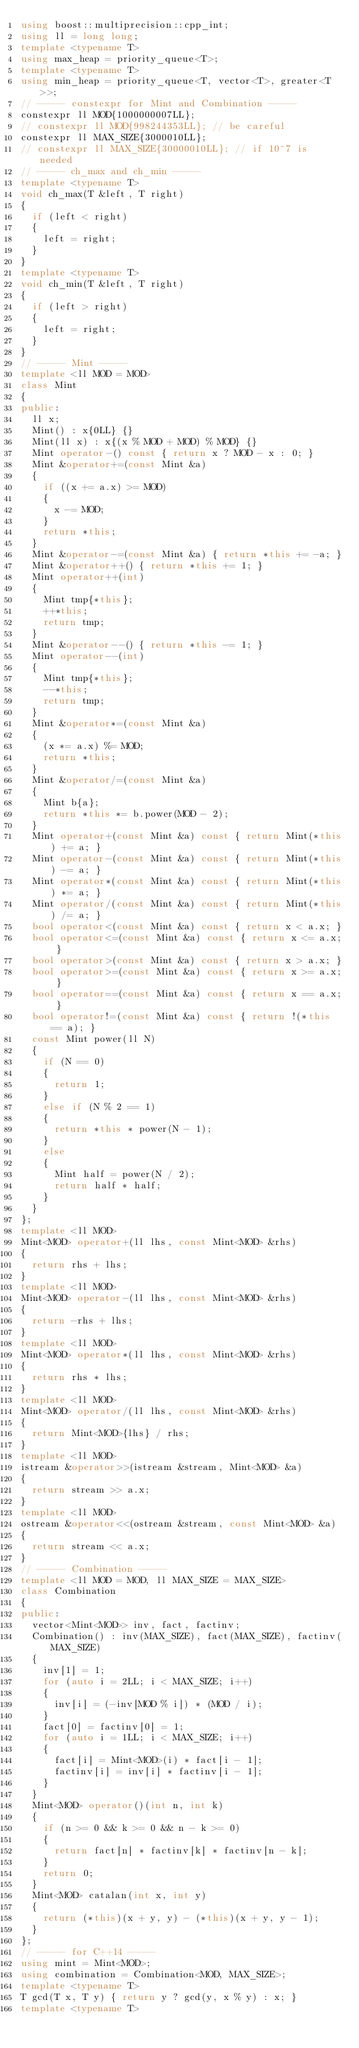<code> <loc_0><loc_0><loc_500><loc_500><_C++_>using boost::multiprecision::cpp_int;
using ll = long long;
template <typename T>
using max_heap = priority_queue<T>;
template <typename T>
using min_heap = priority_queue<T, vector<T>, greater<T>>;
// ----- constexpr for Mint and Combination -----
constexpr ll MOD{1000000007LL};
// constexpr ll MOD{998244353LL}; // be careful
constexpr ll MAX_SIZE{3000010LL};
// constexpr ll MAX_SIZE{30000010LL}; // if 10^7 is needed
// ----- ch_max and ch_min -----
template <typename T>
void ch_max(T &left, T right)
{
  if (left < right)
  {
    left = right;
  }
}
template <typename T>
void ch_min(T &left, T right)
{
  if (left > right)
  {
    left = right;
  }
}
// ----- Mint -----
template <ll MOD = MOD>
class Mint
{
public:
  ll x;
  Mint() : x{0LL} {}
  Mint(ll x) : x{(x % MOD + MOD) % MOD} {}
  Mint operator-() const { return x ? MOD - x : 0; }
  Mint &operator+=(const Mint &a)
  {
    if ((x += a.x) >= MOD)
    {
      x -= MOD;
    }
    return *this;
  }
  Mint &operator-=(const Mint &a) { return *this += -a; }
  Mint &operator++() { return *this += 1; }
  Mint operator++(int)
  {
    Mint tmp{*this};
    ++*this;
    return tmp;
  }
  Mint &operator--() { return *this -= 1; }
  Mint operator--(int)
  {
    Mint tmp{*this};
    --*this;
    return tmp;
  }
  Mint &operator*=(const Mint &a)
  {
    (x *= a.x) %= MOD;
    return *this;
  }
  Mint &operator/=(const Mint &a)
  {
    Mint b{a};
    return *this *= b.power(MOD - 2);
  }
  Mint operator+(const Mint &a) const { return Mint(*this) += a; }
  Mint operator-(const Mint &a) const { return Mint(*this) -= a; }
  Mint operator*(const Mint &a) const { return Mint(*this) *= a; }
  Mint operator/(const Mint &a) const { return Mint(*this) /= a; }
  bool operator<(const Mint &a) const { return x < a.x; }
  bool operator<=(const Mint &a) const { return x <= a.x; }
  bool operator>(const Mint &a) const { return x > a.x; }
  bool operator>=(const Mint &a) const { return x >= a.x; }
  bool operator==(const Mint &a) const { return x == a.x; }
  bool operator!=(const Mint &a) const { return !(*this == a); }
  const Mint power(ll N)
  {
    if (N == 0)
    {
      return 1;
    }
    else if (N % 2 == 1)
    {
      return *this * power(N - 1);
    }
    else
    {
      Mint half = power(N / 2);
      return half * half;
    }
  }
};
template <ll MOD>
Mint<MOD> operator+(ll lhs, const Mint<MOD> &rhs)
{
  return rhs + lhs;
}
template <ll MOD>
Mint<MOD> operator-(ll lhs, const Mint<MOD> &rhs)
{
  return -rhs + lhs;
}
template <ll MOD>
Mint<MOD> operator*(ll lhs, const Mint<MOD> &rhs)
{
  return rhs * lhs;
}
template <ll MOD>
Mint<MOD> operator/(ll lhs, const Mint<MOD> &rhs)
{
  return Mint<MOD>{lhs} / rhs;
}
template <ll MOD>
istream &operator>>(istream &stream, Mint<MOD> &a)
{
  return stream >> a.x;
}
template <ll MOD>
ostream &operator<<(ostream &stream, const Mint<MOD> &a)
{
  return stream << a.x;
}
// ----- Combination -----
template <ll MOD = MOD, ll MAX_SIZE = MAX_SIZE>
class Combination
{
public:
  vector<Mint<MOD>> inv, fact, factinv;
  Combination() : inv(MAX_SIZE), fact(MAX_SIZE), factinv(MAX_SIZE)
  {
    inv[1] = 1;
    for (auto i = 2LL; i < MAX_SIZE; i++)
    {
      inv[i] = (-inv[MOD % i]) * (MOD / i);
    }
    fact[0] = factinv[0] = 1;
    for (auto i = 1LL; i < MAX_SIZE; i++)
    {
      fact[i] = Mint<MOD>(i) * fact[i - 1];
      factinv[i] = inv[i] * factinv[i - 1];
    }
  }
  Mint<MOD> operator()(int n, int k)
  {
    if (n >= 0 && k >= 0 && n - k >= 0)
    {
      return fact[n] * factinv[k] * factinv[n - k];
    }
    return 0;
  }
  Mint<MOD> catalan(int x, int y)
  {
    return (*this)(x + y, y) - (*this)(x + y, y - 1);
  }
};
// ----- for C++14 -----
using mint = Mint<MOD>;
using combination = Combination<MOD, MAX_SIZE>;
template <typename T>
T gcd(T x, T y) { return y ? gcd(y, x % y) : x; }
template <typename T></code> 